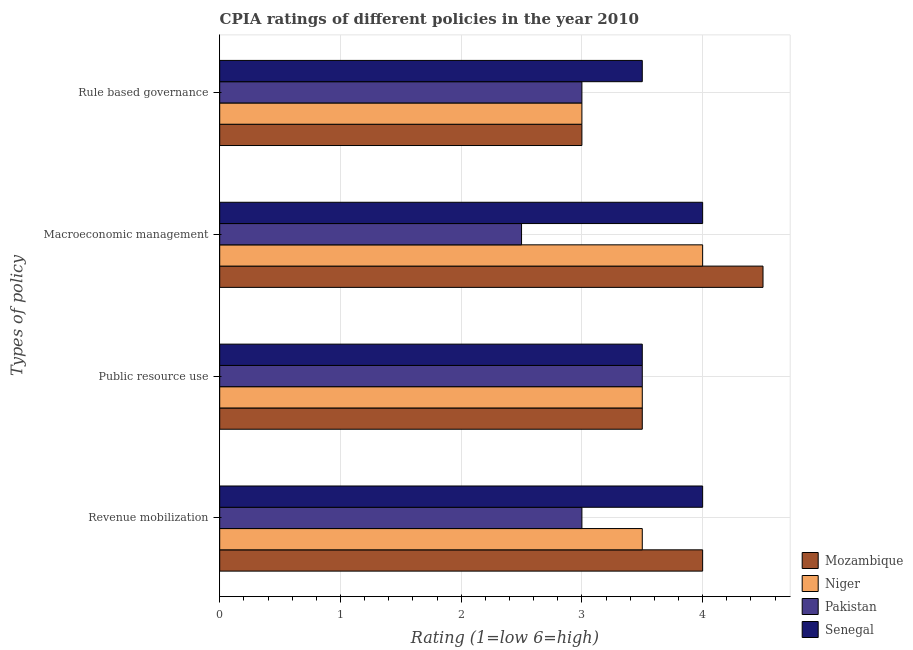How many different coloured bars are there?
Provide a short and direct response. 4. How many groups of bars are there?
Your response must be concise. 4. Are the number of bars per tick equal to the number of legend labels?
Give a very brief answer. Yes. What is the label of the 2nd group of bars from the top?
Offer a very short reply. Macroeconomic management. Across all countries, what is the minimum cpia rating of rule based governance?
Give a very brief answer. 3. In which country was the cpia rating of macroeconomic management maximum?
Your response must be concise. Mozambique. In which country was the cpia rating of rule based governance minimum?
Your answer should be compact. Mozambique. What is the difference between the cpia rating of revenue mobilization in Mozambique and the cpia rating of public resource use in Pakistan?
Your response must be concise. 0.5. What is the average cpia rating of macroeconomic management per country?
Provide a short and direct response. 3.75. In how many countries, is the cpia rating of rule based governance greater than 1.8 ?
Ensure brevity in your answer.  4. What is the ratio of the cpia rating of revenue mobilization in Senegal to that in Pakistan?
Your answer should be very brief. 1.33. Is the cpia rating of revenue mobilization in Niger less than that in Pakistan?
Your answer should be compact. No. Is the difference between the cpia rating of public resource use in Senegal and Pakistan greater than the difference between the cpia rating of rule based governance in Senegal and Pakistan?
Your answer should be very brief. No. What is the difference between the highest and the second highest cpia rating of revenue mobilization?
Offer a terse response. 0. What is the difference between the highest and the lowest cpia rating of macroeconomic management?
Make the answer very short. 2. Is it the case that in every country, the sum of the cpia rating of macroeconomic management and cpia rating of revenue mobilization is greater than the sum of cpia rating of public resource use and cpia rating of rule based governance?
Your response must be concise. No. What does the 4th bar from the top in Rule based governance represents?
Make the answer very short. Mozambique. What does the 2nd bar from the bottom in Macroeconomic management represents?
Provide a short and direct response. Niger. Is it the case that in every country, the sum of the cpia rating of revenue mobilization and cpia rating of public resource use is greater than the cpia rating of macroeconomic management?
Offer a terse response. Yes. How many countries are there in the graph?
Provide a short and direct response. 4. What is the difference between two consecutive major ticks on the X-axis?
Ensure brevity in your answer.  1. Does the graph contain any zero values?
Provide a short and direct response. No. Where does the legend appear in the graph?
Provide a short and direct response. Bottom right. How are the legend labels stacked?
Your answer should be compact. Vertical. What is the title of the graph?
Give a very brief answer. CPIA ratings of different policies in the year 2010. What is the label or title of the X-axis?
Your response must be concise. Rating (1=low 6=high). What is the label or title of the Y-axis?
Make the answer very short. Types of policy. What is the Rating (1=low 6=high) in Mozambique in Revenue mobilization?
Offer a very short reply. 4. What is the Rating (1=low 6=high) of Niger in Revenue mobilization?
Offer a terse response. 3.5. What is the Rating (1=low 6=high) of Pakistan in Revenue mobilization?
Your response must be concise. 3. What is the Rating (1=low 6=high) in Mozambique in Public resource use?
Provide a succinct answer. 3.5. What is the Rating (1=low 6=high) in Niger in Macroeconomic management?
Your response must be concise. 4. What is the Rating (1=low 6=high) of Pakistan in Rule based governance?
Offer a very short reply. 3. What is the Rating (1=low 6=high) of Senegal in Rule based governance?
Make the answer very short. 3.5. Across all Types of policy, what is the maximum Rating (1=low 6=high) of Mozambique?
Your answer should be compact. 4.5. Across all Types of policy, what is the maximum Rating (1=low 6=high) of Niger?
Keep it short and to the point. 4. Across all Types of policy, what is the maximum Rating (1=low 6=high) of Pakistan?
Give a very brief answer. 3.5. Across all Types of policy, what is the maximum Rating (1=low 6=high) in Senegal?
Your answer should be compact. 4. Across all Types of policy, what is the minimum Rating (1=low 6=high) of Niger?
Provide a short and direct response. 3. Across all Types of policy, what is the minimum Rating (1=low 6=high) of Pakistan?
Provide a short and direct response. 2.5. Across all Types of policy, what is the minimum Rating (1=low 6=high) of Senegal?
Your answer should be very brief. 3.5. What is the total Rating (1=low 6=high) of Niger in the graph?
Ensure brevity in your answer.  14. What is the total Rating (1=low 6=high) in Pakistan in the graph?
Make the answer very short. 12. What is the total Rating (1=low 6=high) in Senegal in the graph?
Provide a succinct answer. 15. What is the difference between the Rating (1=low 6=high) in Niger in Revenue mobilization and that in Public resource use?
Ensure brevity in your answer.  0. What is the difference between the Rating (1=low 6=high) of Pakistan in Revenue mobilization and that in Public resource use?
Ensure brevity in your answer.  -0.5. What is the difference between the Rating (1=low 6=high) in Senegal in Revenue mobilization and that in Public resource use?
Make the answer very short. 0.5. What is the difference between the Rating (1=low 6=high) of Mozambique in Revenue mobilization and that in Macroeconomic management?
Offer a terse response. -0.5. What is the difference between the Rating (1=low 6=high) of Mozambique in Revenue mobilization and that in Rule based governance?
Offer a very short reply. 1. What is the difference between the Rating (1=low 6=high) of Senegal in Revenue mobilization and that in Rule based governance?
Offer a very short reply. 0.5. What is the difference between the Rating (1=low 6=high) of Pakistan in Public resource use and that in Macroeconomic management?
Provide a succinct answer. 1. What is the difference between the Rating (1=low 6=high) in Mozambique in Public resource use and that in Rule based governance?
Make the answer very short. 0.5. What is the difference between the Rating (1=low 6=high) of Mozambique in Macroeconomic management and that in Rule based governance?
Provide a succinct answer. 1.5. What is the difference between the Rating (1=low 6=high) of Niger in Macroeconomic management and that in Rule based governance?
Provide a short and direct response. 1. What is the difference between the Rating (1=low 6=high) in Mozambique in Revenue mobilization and the Rating (1=low 6=high) in Pakistan in Public resource use?
Your answer should be very brief. 0.5. What is the difference between the Rating (1=low 6=high) of Niger in Revenue mobilization and the Rating (1=low 6=high) of Pakistan in Public resource use?
Make the answer very short. 0. What is the difference between the Rating (1=low 6=high) in Mozambique in Revenue mobilization and the Rating (1=low 6=high) in Pakistan in Macroeconomic management?
Give a very brief answer. 1.5. What is the difference between the Rating (1=low 6=high) of Mozambique in Revenue mobilization and the Rating (1=low 6=high) of Senegal in Macroeconomic management?
Your answer should be very brief. 0. What is the difference between the Rating (1=low 6=high) in Niger in Revenue mobilization and the Rating (1=low 6=high) in Pakistan in Macroeconomic management?
Keep it short and to the point. 1. What is the difference between the Rating (1=low 6=high) in Pakistan in Revenue mobilization and the Rating (1=low 6=high) in Senegal in Macroeconomic management?
Your answer should be very brief. -1. What is the difference between the Rating (1=low 6=high) in Niger in Revenue mobilization and the Rating (1=low 6=high) in Pakistan in Rule based governance?
Your answer should be compact. 0.5. What is the difference between the Rating (1=low 6=high) of Niger in Revenue mobilization and the Rating (1=low 6=high) of Senegal in Rule based governance?
Your answer should be compact. 0. What is the difference between the Rating (1=low 6=high) of Pakistan in Revenue mobilization and the Rating (1=low 6=high) of Senegal in Rule based governance?
Make the answer very short. -0.5. What is the difference between the Rating (1=low 6=high) of Mozambique in Public resource use and the Rating (1=low 6=high) of Pakistan in Macroeconomic management?
Your answer should be very brief. 1. What is the difference between the Rating (1=low 6=high) of Niger in Public resource use and the Rating (1=low 6=high) of Pakistan in Macroeconomic management?
Offer a very short reply. 1. What is the difference between the Rating (1=low 6=high) of Pakistan in Public resource use and the Rating (1=low 6=high) of Senegal in Macroeconomic management?
Your answer should be very brief. -0.5. What is the difference between the Rating (1=low 6=high) of Mozambique in Public resource use and the Rating (1=low 6=high) of Pakistan in Rule based governance?
Provide a short and direct response. 0.5. What is the difference between the Rating (1=low 6=high) of Niger in Public resource use and the Rating (1=low 6=high) of Pakistan in Rule based governance?
Make the answer very short. 0.5. What is the difference between the Rating (1=low 6=high) of Mozambique in Macroeconomic management and the Rating (1=low 6=high) of Niger in Rule based governance?
Keep it short and to the point. 1.5. What is the average Rating (1=low 6=high) in Mozambique per Types of policy?
Ensure brevity in your answer.  3.75. What is the average Rating (1=low 6=high) in Niger per Types of policy?
Provide a succinct answer. 3.5. What is the average Rating (1=low 6=high) of Senegal per Types of policy?
Provide a short and direct response. 3.75. What is the difference between the Rating (1=low 6=high) of Mozambique and Rating (1=low 6=high) of Niger in Revenue mobilization?
Keep it short and to the point. 0.5. What is the difference between the Rating (1=low 6=high) of Mozambique and Rating (1=low 6=high) of Senegal in Revenue mobilization?
Make the answer very short. 0. What is the difference between the Rating (1=low 6=high) in Niger and Rating (1=low 6=high) in Pakistan in Revenue mobilization?
Keep it short and to the point. 0.5. What is the difference between the Rating (1=low 6=high) in Niger and Rating (1=low 6=high) in Senegal in Revenue mobilization?
Make the answer very short. -0.5. What is the difference between the Rating (1=low 6=high) in Pakistan and Rating (1=low 6=high) in Senegal in Revenue mobilization?
Your answer should be compact. -1. What is the difference between the Rating (1=low 6=high) of Mozambique and Rating (1=low 6=high) of Niger in Public resource use?
Give a very brief answer. 0. What is the difference between the Rating (1=low 6=high) of Mozambique and Rating (1=low 6=high) of Senegal in Public resource use?
Your response must be concise. 0. What is the difference between the Rating (1=low 6=high) in Niger and Rating (1=low 6=high) in Pakistan in Public resource use?
Provide a succinct answer. 0. What is the difference between the Rating (1=low 6=high) in Niger and Rating (1=low 6=high) in Senegal in Public resource use?
Provide a short and direct response. 0. What is the difference between the Rating (1=low 6=high) in Pakistan and Rating (1=low 6=high) in Senegal in Public resource use?
Keep it short and to the point. 0. What is the difference between the Rating (1=low 6=high) of Niger and Rating (1=low 6=high) of Pakistan in Macroeconomic management?
Offer a terse response. 1.5. What is the difference between the Rating (1=low 6=high) of Niger and Rating (1=low 6=high) of Senegal in Macroeconomic management?
Your answer should be compact. 0. What is the difference between the Rating (1=low 6=high) of Mozambique and Rating (1=low 6=high) of Niger in Rule based governance?
Offer a terse response. 0. What is the difference between the Rating (1=low 6=high) in Niger and Rating (1=low 6=high) in Senegal in Rule based governance?
Keep it short and to the point. -0.5. What is the ratio of the Rating (1=low 6=high) in Mozambique in Revenue mobilization to that in Public resource use?
Provide a succinct answer. 1.14. What is the ratio of the Rating (1=low 6=high) of Niger in Revenue mobilization to that in Public resource use?
Your answer should be very brief. 1. What is the ratio of the Rating (1=low 6=high) in Pakistan in Revenue mobilization to that in Macroeconomic management?
Provide a short and direct response. 1.2. What is the ratio of the Rating (1=low 6=high) in Senegal in Revenue mobilization to that in Macroeconomic management?
Make the answer very short. 1. What is the ratio of the Rating (1=low 6=high) of Niger in Revenue mobilization to that in Rule based governance?
Offer a terse response. 1.17. What is the ratio of the Rating (1=low 6=high) of Pakistan in Revenue mobilization to that in Rule based governance?
Provide a succinct answer. 1. What is the ratio of the Rating (1=low 6=high) of Senegal in Revenue mobilization to that in Rule based governance?
Offer a terse response. 1.14. What is the ratio of the Rating (1=low 6=high) of Mozambique in Public resource use to that in Macroeconomic management?
Ensure brevity in your answer.  0.78. What is the ratio of the Rating (1=low 6=high) in Pakistan in Public resource use to that in Macroeconomic management?
Keep it short and to the point. 1.4. What is the ratio of the Rating (1=low 6=high) in Niger in Public resource use to that in Rule based governance?
Keep it short and to the point. 1.17. What is the ratio of the Rating (1=low 6=high) of Niger in Macroeconomic management to that in Rule based governance?
Offer a terse response. 1.33. What is the ratio of the Rating (1=low 6=high) in Senegal in Macroeconomic management to that in Rule based governance?
Offer a terse response. 1.14. What is the difference between the highest and the second highest Rating (1=low 6=high) in Niger?
Your answer should be compact. 0.5. 